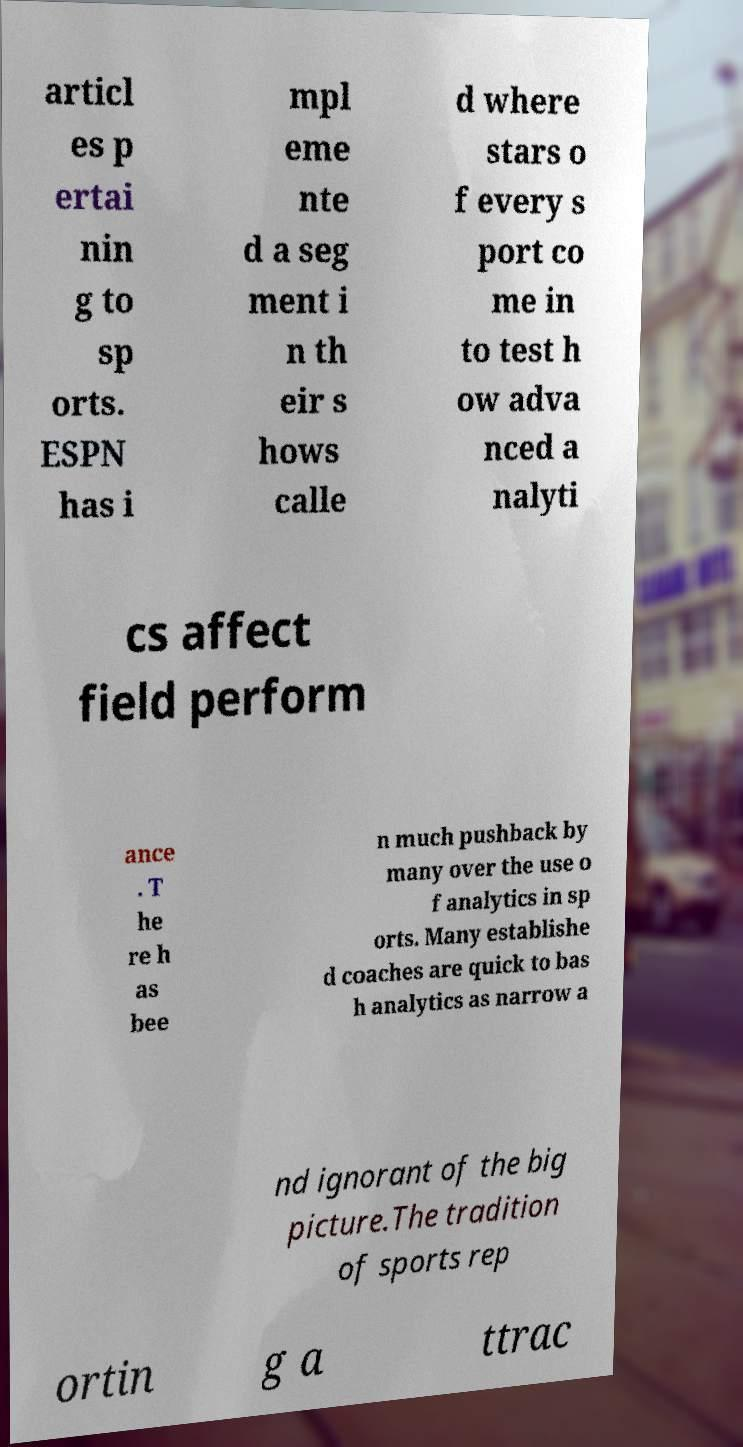Can you accurately transcribe the text from the provided image for me? articl es p ertai nin g to sp orts. ESPN has i mpl eme nte d a seg ment i n th eir s hows calle d where stars o f every s port co me in to test h ow adva nced a nalyti cs affect field perform ance . T he re h as bee n much pushback by many over the use o f analytics in sp orts. Many establishe d coaches are quick to bas h analytics as narrow a nd ignorant of the big picture.The tradition of sports rep ortin g a ttrac 